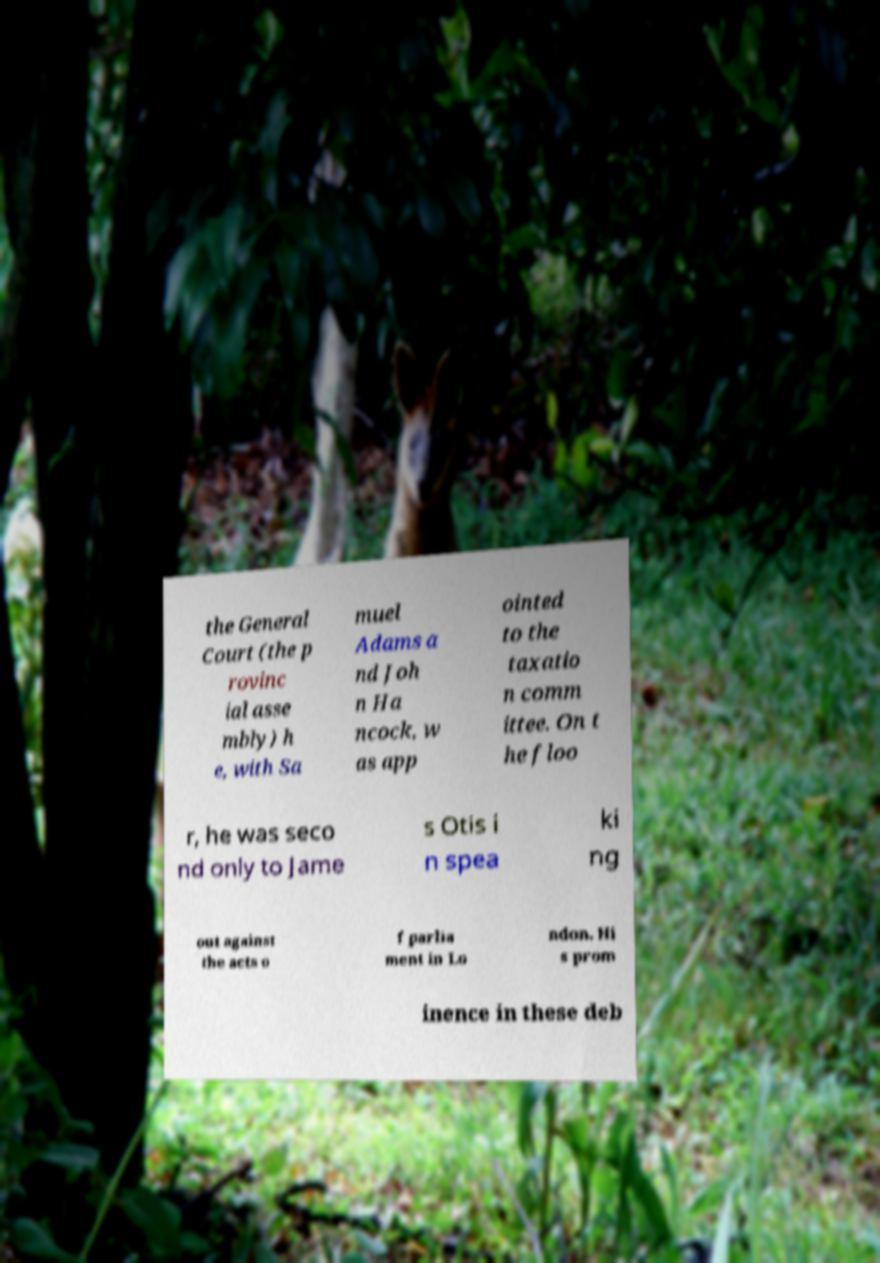There's text embedded in this image that I need extracted. Can you transcribe it verbatim? the General Court (the p rovinc ial asse mbly) h e, with Sa muel Adams a nd Joh n Ha ncock, w as app ointed to the taxatio n comm ittee. On t he floo r, he was seco nd only to Jame s Otis i n spea ki ng out against the acts o f parlia ment in Lo ndon. Hi s prom inence in these deb 